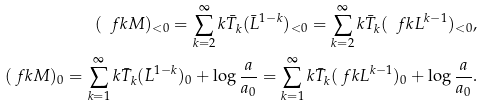<formula> <loc_0><loc_0><loc_500><loc_500>( \ f k M ) _ { < 0 } = \sum _ { k = 2 } ^ { \infty } k \bar { T } _ { k } ( \bar { L } ^ { 1 - k } ) _ { < 0 } = \sum _ { k = 2 } ^ { \infty } k \bar { T } _ { k } ( \ f k L ^ { k - 1 } ) _ { < 0 } , \\ ( \ f k M ) _ { 0 } = \sum _ { k = 1 } ^ { \infty } k \bar { T } _ { k } ( \bar { L } ^ { 1 - k } ) _ { 0 } + \log \frac { a } { a _ { 0 } } = \sum _ { k = 1 } ^ { \infty } k \bar { T } _ { k } ( \ f k L ^ { k - 1 } ) _ { 0 } + \log \frac { a } { a _ { 0 } } .</formula> 